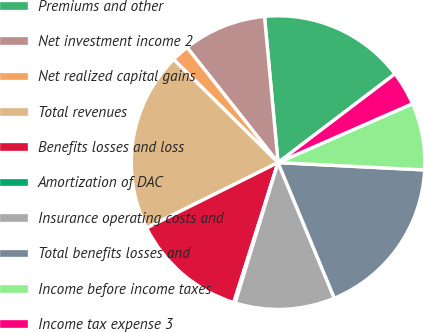<chart> <loc_0><loc_0><loc_500><loc_500><pie_chart><fcel>Premiums and other<fcel>Net investment income 2<fcel>Net realized capital gains<fcel>Total revenues<fcel>Benefits losses and loss<fcel>Amortization of DAC<fcel>Insurance operating costs and<fcel>Total benefits losses and<fcel>Income before income taxes<fcel>Income tax expense 3<nl><fcel>16.14%<fcel>9.17%<fcel>1.96%<fcel>19.74%<fcel>12.78%<fcel>0.16%<fcel>10.98%<fcel>17.94%<fcel>7.37%<fcel>3.76%<nl></chart> 